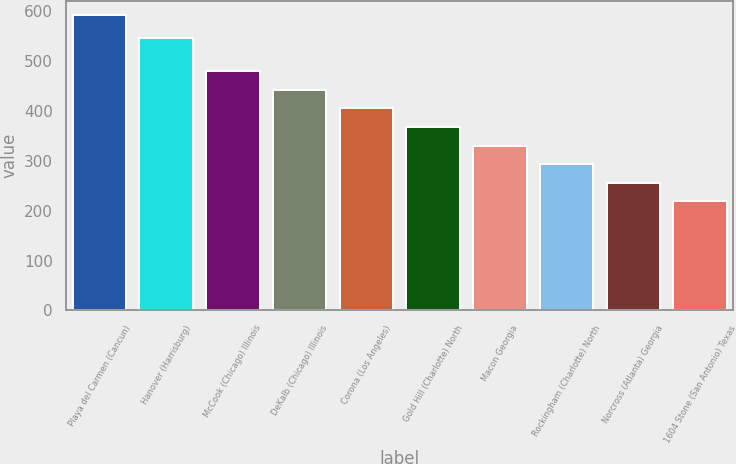Convert chart. <chart><loc_0><loc_0><loc_500><loc_500><bar_chart><fcel>Playa del Carmen (Cancun)<fcel>Hanover (Harrisburg)<fcel>McCook (Chicago) Illinois<fcel>DeKalb (Chicago) Illinois<fcel>Corona (Los Angeles)<fcel>Gold Hill (Charlotte) North<fcel>Macon Georgia<fcel>Rockingham (Charlotte) North<fcel>Norcross (Atlanta) Georgia<fcel>1604 Stone (San Antonio) Texas<nl><fcel>592.2<fcel>547.7<fcel>480.15<fcel>442.8<fcel>405.45<fcel>368.1<fcel>330.75<fcel>293.4<fcel>256.05<fcel>218.7<nl></chart> 